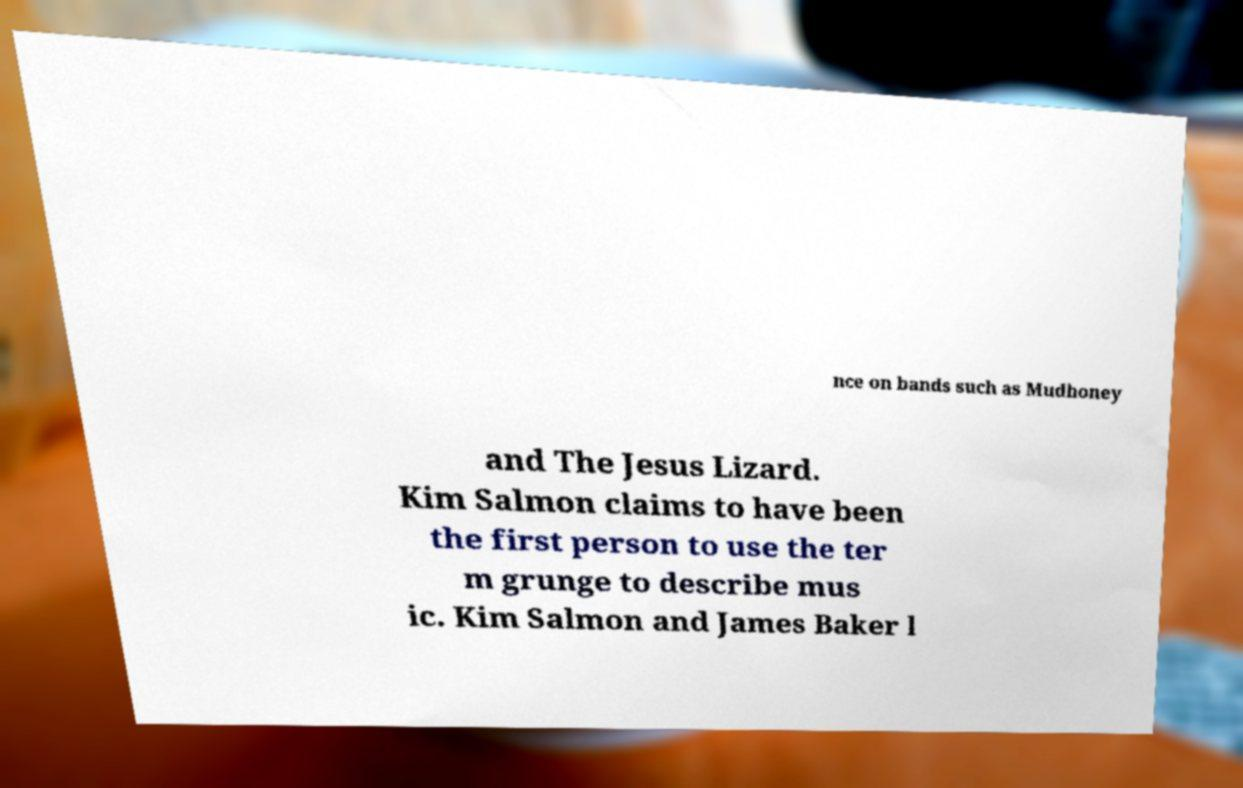Please read and relay the text visible in this image. What does it say? nce on bands such as Mudhoney and The Jesus Lizard. Kim Salmon claims to have been the first person to use the ter m grunge to describe mus ic. Kim Salmon and James Baker l 